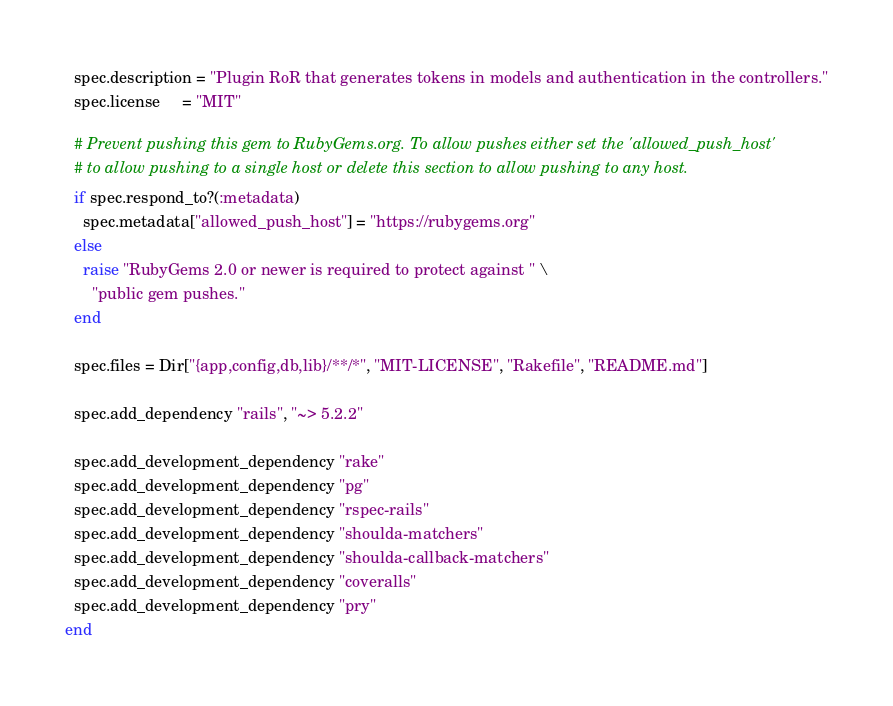Convert code to text. <code><loc_0><loc_0><loc_500><loc_500><_Ruby_>  spec.description = "Plugin RoR that generates tokens in models and authentication in the controllers."
  spec.license     = "MIT"

  # Prevent pushing this gem to RubyGems.org. To allow pushes either set the 'allowed_push_host'
  # to allow pushing to a single host or delete this section to allow pushing to any host.
  if spec.respond_to?(:metadata)
    spec.metadata["allowed_push_host"] = "https://rubygems.org"
  else
    raise "RubyGems 2.0 or newer is required to protect against " \
      "public gem pushes."
  end

  spec.files = Dir["{app,config,db,lib}/**/*", "MIT-LICENSE", "Rakefile", "README.md"]

  spec.add_dependency "rails", "~> 5.2.2"

  spec.add_development_dependency "rake"
  spec.add_development_dependency "pg"
  spec.add_development_dependency "rspec-rails"
  spec.add_development_dependency "shoulda-matchers"
  spec.add_development_dependency "shoulda-callback-matchers"
  spec.add_development_dependency "coveralls"
  spec.add_development_dependency "pry"
end
</code> 